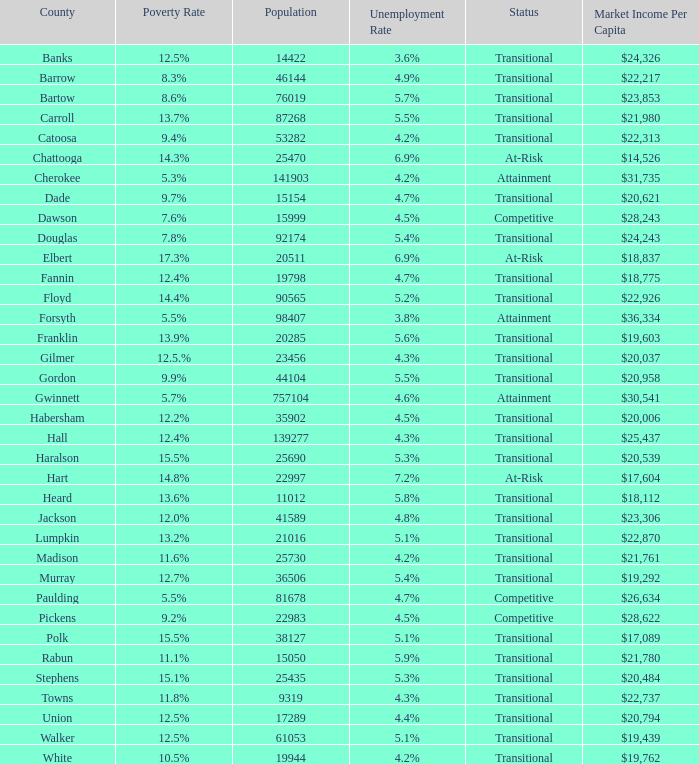What is the unemployment rate for the county with a market income per capita of $20,958? 1.0. Parse the table in full. {'header': ['County', 'Poverty Rate', 'Population', 'Unemployment Rate', 'Status', 'Market Income Per Capita'], 'rows': [['Banks', '12.5%', '14422', '3.6%', 'Transitional', '$24,326'], ['Barrow', '8.3%', '46144', '4.9%', 'Transitional', '$22,217'], ['Bartow', '8.6%', '76019', '5.7%', 'Transitional', '$23,853'], ['Carroll', '13.7%', '87268', '5.5%', 'Transitional', '$21,980'], ['Catoosa', '9.4%', '53282', '4.2%', 'Transitional', '$22,313'], ['Chattooga', '14.3%', '25470', '6.9%', 'At-Risk', '$14,526'], ['Cherokee', '5.3%', '141903', '4.2%', 'Attainment', '$31,735'], ['Dade', '9.7%', '15154', '4.7%', 'Transitional', '$20,621'], ['Dawson', '7.6%', '15999', '4.5%', 'Competitive', '$28,243'], ['Douglas', '7.8%', '92174', '5.4%', 'Transitional', '$24,243'], ['Elbert', '17.3%', '20511', '6.9%', 'At-Risk', '$18,837'], ['Fannin', '12.4%', '19798', '4.7%', 'Transitional', '$18,775'], ['Floyd', '14.4%', '90565', '5.2%', 'Transitional', '$22,926'], ['Forsyth', '5.5%', '98407', '3.8%', 'Attainment', '$36,334'], ['Franklin', '13.9%', '20285', '5.6%', 'Transitional', '$19,603'], ['Gilmer', '12.5.%', '23456', '4.3%', 'Transitional', '$20,037'], ['Gordon', '9.9%', '44104', '5.5%', 'Transitional', '$20,958'], ['Gwinnett', '5.7%', '757104', '4.6%', 'Attainment', '$30,541'], ['Habersham', '12.2%', '35902', '4.5%', 'Transitional', '$20,006'], ['Hall', '12.4%', '139277', '4.3%', 'Transitional', '$25,437'], ['Haralson', '15.5%', '25690', '5.3%', 'Transitional', '$20,539'], ['Hart', '14.8%', '22997', '7.2%', 'At-Risk', '$17,604'], ['Heard', '13.6%', '11012', '5.8%', 'Transitional', '$18,112'], ['Jackson', '12.0%', '41589', '4.8%', 'Transitional', '$23,306'], ['Lumpkin', '13.2%', '21016', '5.1%', 'Transitional', '$22,870'], ['Madison', '11.6%', '25730', '4.2%', 'Transitional', '$21,761'], ['Murray', '12.7%', '36506', '5.4%', 'Transitional', '$19,292'], ['Paulding', '5.5%', '81678', '4.7%', 'Competitive', '$26,634'], ['Pickens', '9.2%', '22983', '4.5%', 'Competitive', '$28,622'], ['Polk', '15.5%', '38127', '5.1%', 'Transitional', '$17,089'], ['Rabun', '11.1%', '15050', '5.9%', 'Transitional', '$21,780'], ['Stephens', '15.1%', '25435', '5.3%', 'Transitional', '$20,484'], ['Towns', '11.8%', '9319', '4.3%', 'Transitional', '$22,737'], ['Union', '12.5%', '17289', '4.4%', 'Transitional', '$20,794'], ['Walker', '12.5%', '61053', '5.1%', 'Transitional', '$19,439'], ['White', '10.5%', '19944', '4.2%', 'Transitional', '$19,762']]} 